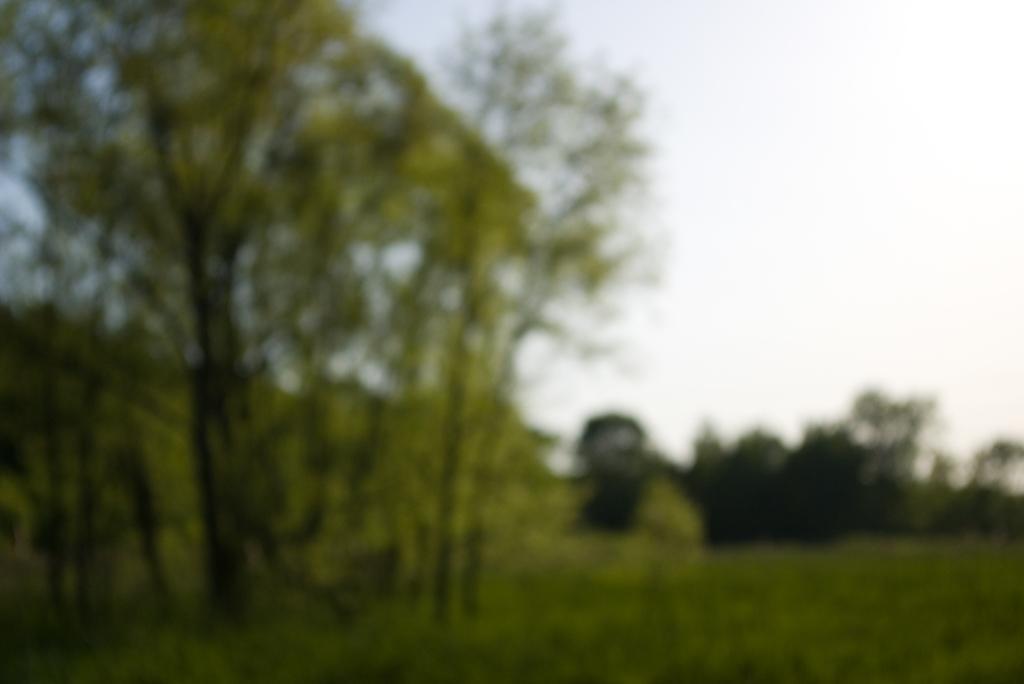Could you give a brief overview of what you see in this image? This image is slightly blurred, where we can see the grass, trees and the sky in the background. 